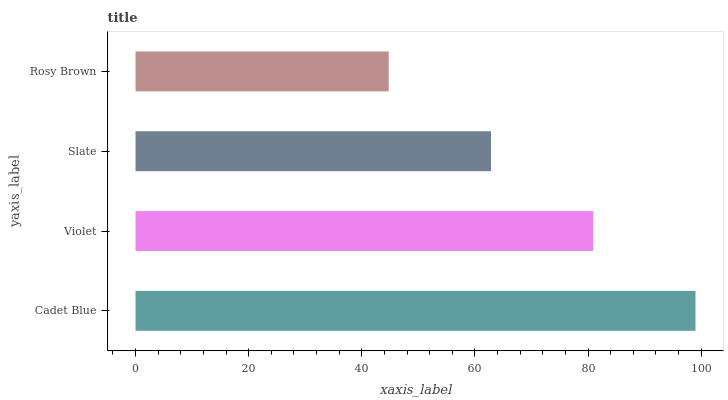Is Rosy Brown the minimum?
Answer yes or no. Yes. Is Cadet Blue the maximum?
Answer yes or no. Yes. Is Violet the minimum?
Answer yes or no. No. Is Violet the maximum?
Answer yes or no. No. Is Cadet Blue greater than Violet?
Answer yes or no. Yes. Is Violet less than Cadet Blue?
Answer yes or no. Yes. Is Violet greater than Cadet Blue?
Answer yes or no. No. Is Cadet Blue less than Violet?
Answer yes or no. No. Is Violet the high median?
Answer yes or no. Yes. Is Slate the low median?
Answer yes or no. Yes. Is Slate the high median?
Answer yes or no. No. Is Violet the low median?
Answer yes or no. No. 